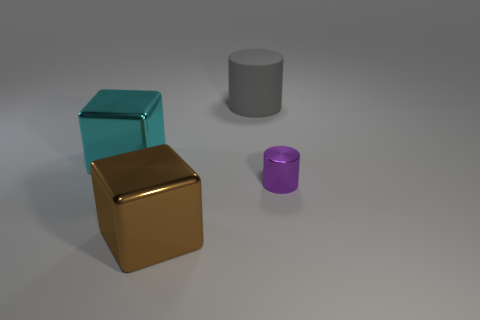There is a large matte thing to the left of the cylinder that is right of the big gray object; what number of rubber cylinders are behind it?
Your response must be concise. 0. What material is the big object that is behind the tiny shiny thing and on the right side of the cyan shiny object?
Your answer should be compact. Rubber. The small shiny object has what color?
Your answer should be very brief. Purple. Is the number of large shiny objects behind the large brown metallic block greater than the number of tiny purple objects behind the small thing?
Your response must be concise. Yes. The thing that is behind the cyan block is what color?
Ensure brevity in your answer.  Gray. There is a cube that is behind the brown object; is its size the same as the metallic thing right of the brown thing?
Make the answer very short. No. What number of things are either small red spheres or brown shiny objects?
Offer a very short reply. 1. What material is the large object on the right side of the big thing in front of the tiny purple metal object?
Your answer should be compact. Rubber. What number of purple objects are the same shape as the big gray thing?
Offer a terse response. 1. How many objects are big things on the right side of the brown metallic block or shiny objects to the left of the brown metallic object?
Offer a terse response. 2. 